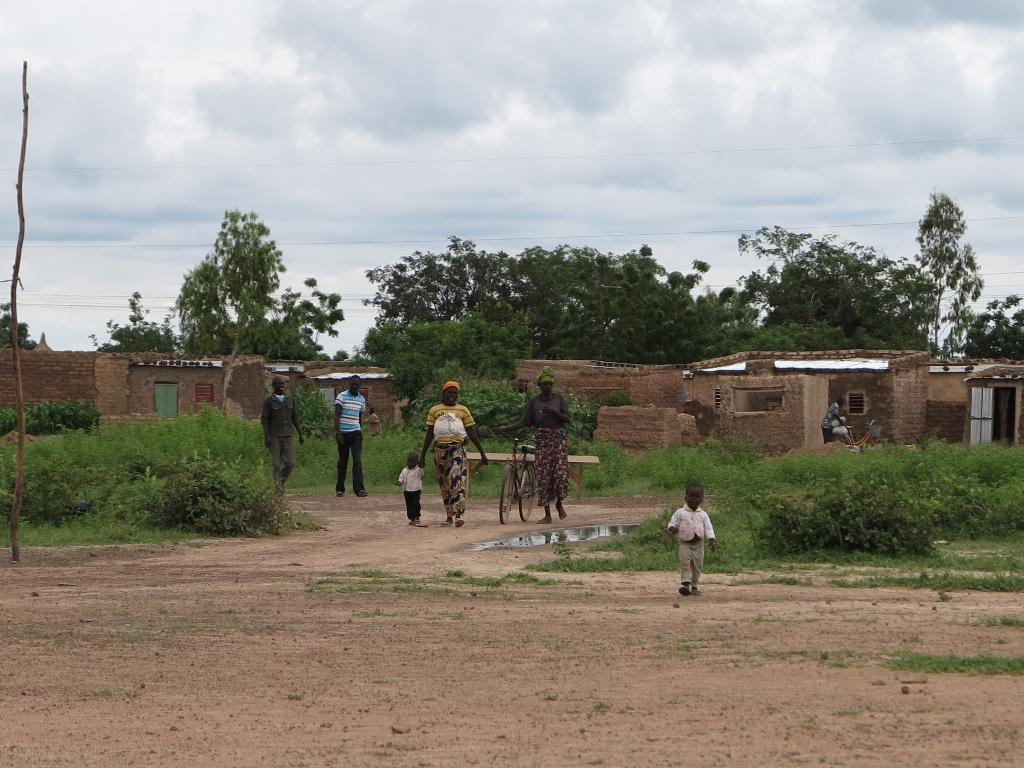What is happening with the group of people in the image? The people are walking in the image. Can you describe the person in front of the group? There is a person holding a bicycle in front of the group. What can be seen in the background of the image? There are houses and trees with green color in the background. How would you describe the sky in the image? The sky is in white color. What type of soup is being served to the writer in the image? There is no soup or writer present in the image; it features a group of people walking with a person holding a bicycle in front. 